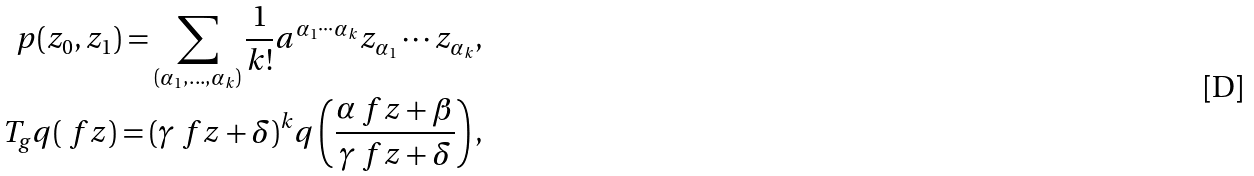Convert formula to latex. <formula><loc_0><loc_0><loc_500><loc_500>p ( z _ { 0 } , z _ { 1 } ) = \sum _ { ( \alpha _ { 1 } , \dots , \alpha _ { k } ) } \frac { 1 } { k ! } a ^ { \alpha _ { 1 } \cdots \alpha _ { k } } z _ { \alpha _ { 1 } } \cdots z _ { \alpha _ { k } } , \\ T _ { g } q ( \ f z ) = ( \gamma \ f z + \delta ) ^ { k } q \left ( \frac { \alpha \ f z + \beta } { \gamma \ f z + \delta } \right ) ,</formula> 